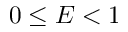<formula> <loc_0><loc_0><loc_500><loc_500>0 \leq E < 1</formula> 